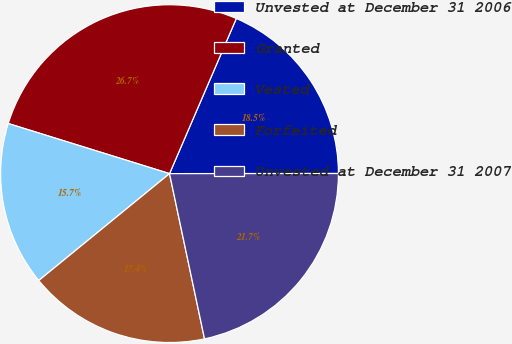Convert chart. <chart><loc_0><loc_0><loc_500><loc_500><pie_chart><fcel>Unvested at December 31 2006<fcel>Granted<fcel>Vested<fcel>Forfeited<fcel>Unvested at December 31 2007<nl><fcel>18.52%<fcel>26.68%<fcel>15.7%<fcel>17.42%<fcel>21.69%<nl></chart> 